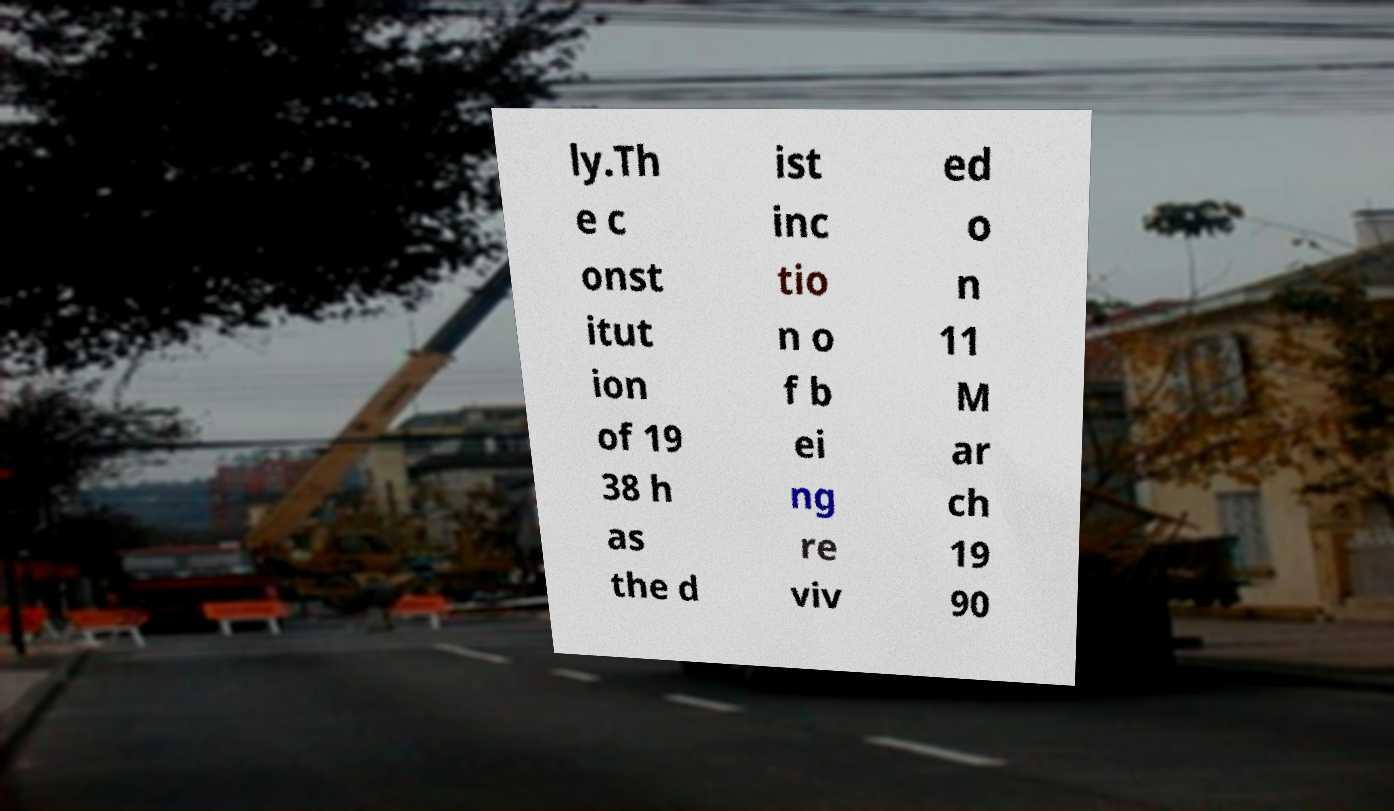Can you accurately transcribe the text from the provided image for me? ly.Th e c onst itut ion of 19 38 h as the d ist inc tio n o f b ei ng re viv ed o n 11 M ar ch 19 90 